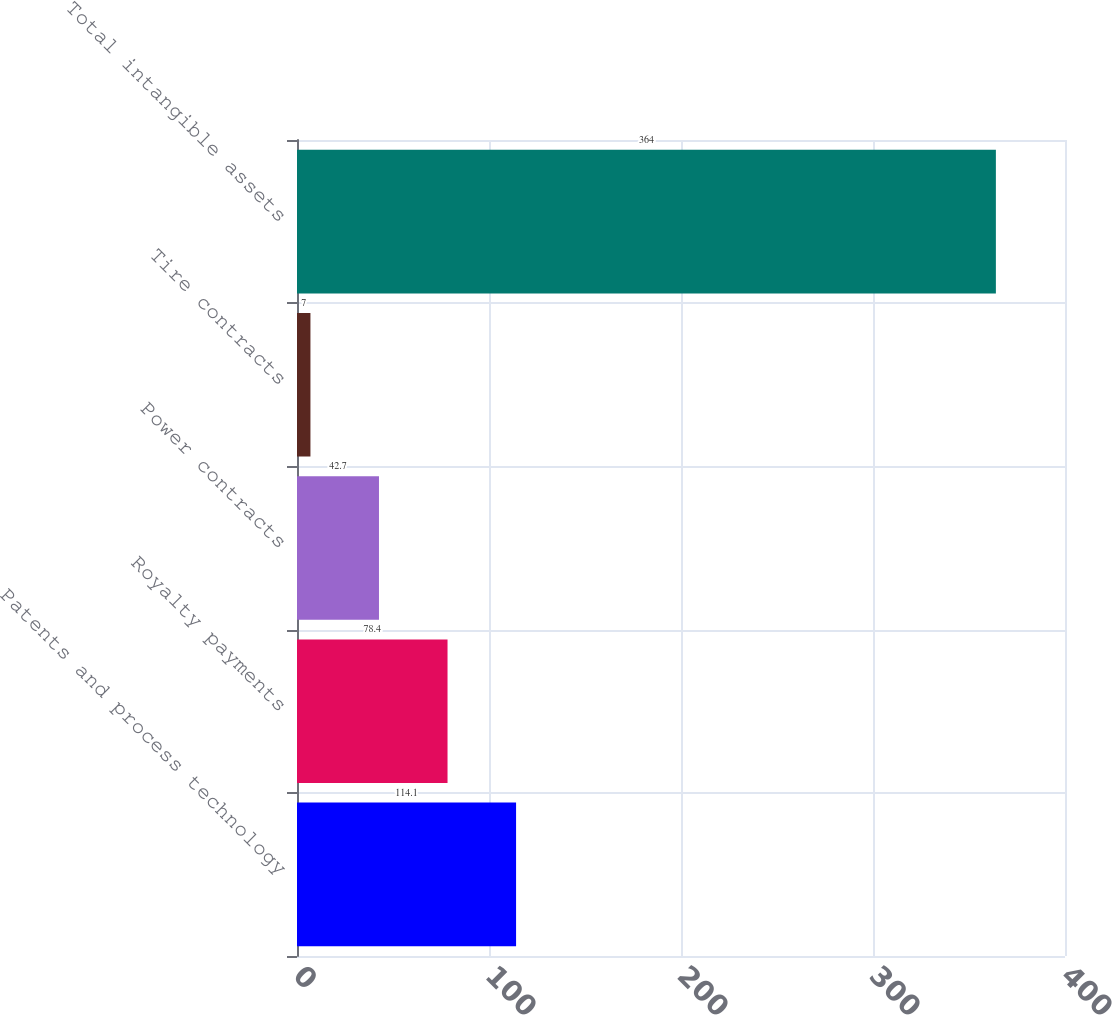Convert chart. <chart><loc_0><loc_0><loc_500><loc_500><bar_chart><fcel>Patents and process technology<fcel>Royalty payments<fcel>Power contracts<fcel>Tire contracts<fcel>Total intangible assets<nl><fcel>114.1<fcel>78.4<fcel>42.7<fcel>7<fcel>364<nl></chart> 